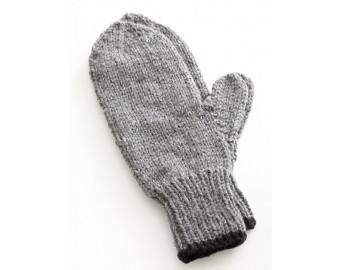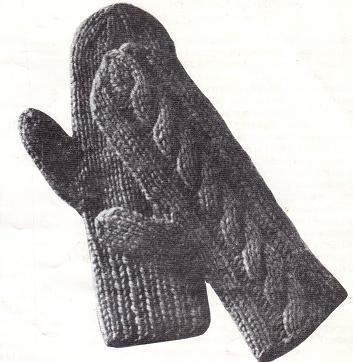The first image is the image on the left, the second image is the image on the right. Given the left and right images, does the statement "Two pairs of traditional mittens are shown, with the fingers covered by one rounded section." hold true? Answer yes or no. Yes. 